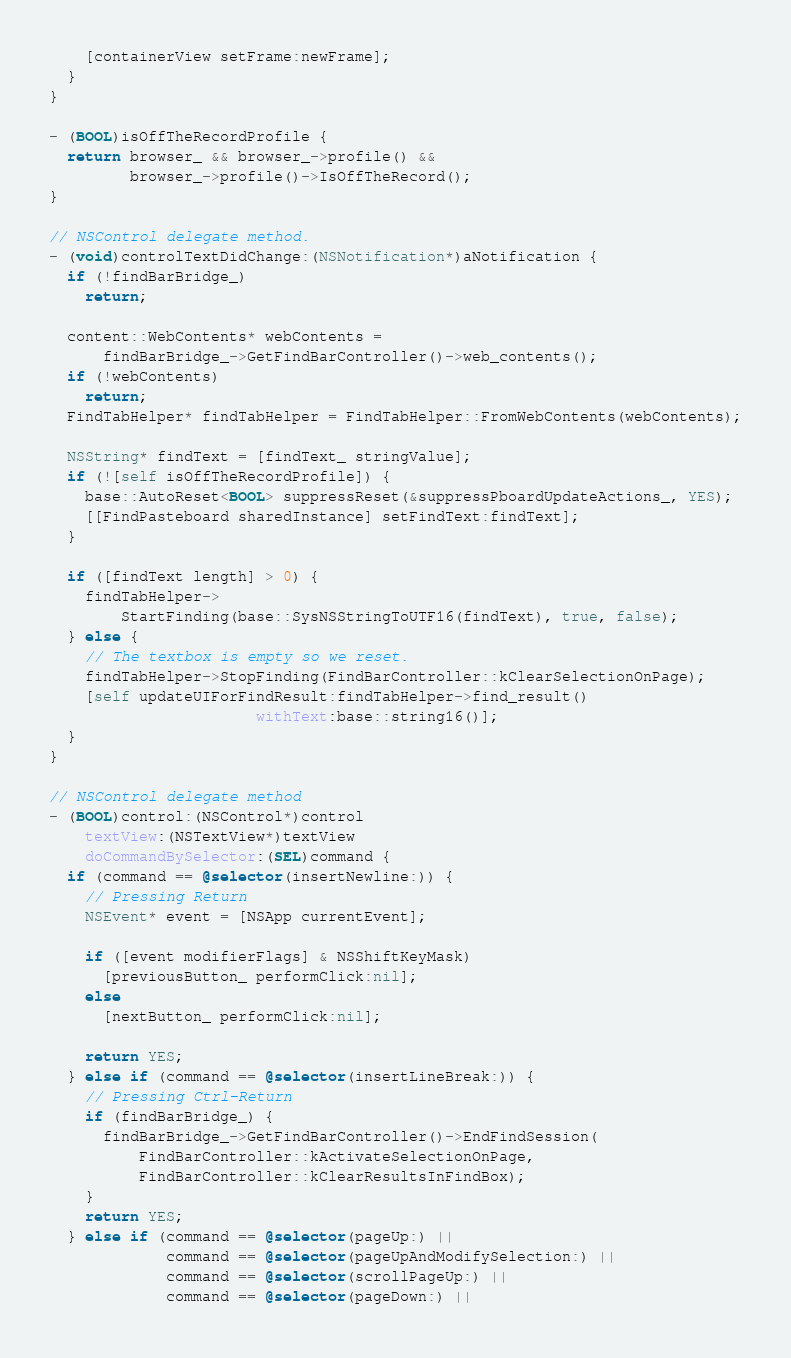<code> <loc_0><loc_0><loc_500><loc_500><_ObjectiveC_>    [containerView setFrame:newFrame];
  }
}

- (BOOL)isOffTheRecordProfile {
  return browser_ && browser_->profile() &&
         browser_->profile()->IsOffTheRecord();
}

// NSControl delegate method.
- (void)controlTextDidChange:(NSNotification*)aNotification {
  if (!findBarBridge_)
    return;

  content::WebContents* webContents =
      findBarBridge_->GetFindBarController()->web_contents();
  if (!webContents)
    return;
  FindTabHelper* findTabHelper = FindTabHelper::FromWebContents(webContents);

  NSString* findText = [findText_ stringValue];
  if (![self isOffTheRecordProfile]) {
    base::AutoReset<BOOL> suppressReset(&suppressPboardUpdateActions_, YES);
    [[FindPasteboard sharedInstance] setFindText:findText];
  }

  if ([findText length] > 0) {
    findTabHelper->
        StartFinding(base::SysNSStringToUTF16(findText), true, false);
  } else {
    // The textbox is empty so we reset.
    findTabHelper->StopFinding(FindBarController::kClearSelectionOnPage);
    [self updateUIForFindResult:findTabHelper->find_result()
                       withText:base::string16()];
  }
}

// NSControl delegate method
- (BOOL)control:(NSControl*)control
    textView:(NSTextView*)textView
    doCommandBySelector:(SEL)command {
  if (command == @selector(insertNewline:)) {
    // Pressing Return
    NSEvent* event = [NSApp currentEvent];

    if ([event modifierFlags] & NSShiftKeyMask)
      [previousButton_ performClick:nil];
    else
      [nextButton_ performClick:nil];

    return YES;
  } else if (command == @selector(insertLineBreak:)) {
    // Pressing Ctrl-Return
    if (findBarBridge_) {
      findBarBridge_->GetFindBarController()->EndFindSession(
          FindBarController::kActivateSelectionOnPage,
          FindBarController::kClearResultsInFindBox);
    }
    return YES;
  } else if (command == @selector(pageUp:) ||
             command == @selector(pageUpAndModifySelection:) ||
             command == @selector(scrollPageUp:) ||
             command == @selector(pageDown:) ||</code> 